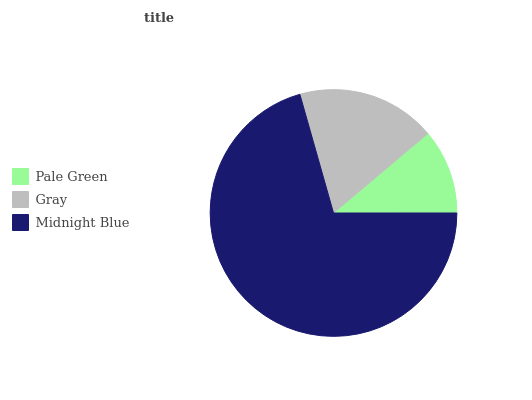Is Pale Green the minimum?
Answer yes or no. Yes. Is Midnight Blue the maximum?
Answer yes or no. Yes. Is Gray the minimum?
Answer yes or no. No. Is Gray the maximum?
Answer yes or no. No. Is Gray greater than Pale Green?
Answer yes or no. Yes. Is Pale Green less than Gray?
Answer yes or no. Yes. Is Pale Green greater than Gray?
Answer yes or no. No. Is Gray less than Pale Green?
Answer yes or no. No. Is Gray the high median?
Answer yes or no. Yes. Is Gray the low median?
Answer yes or no. Yes. Is Pale Green the high median?
Answer yes or no. No. Is Midnight Blue the low median?
Answer yes or no. No. 